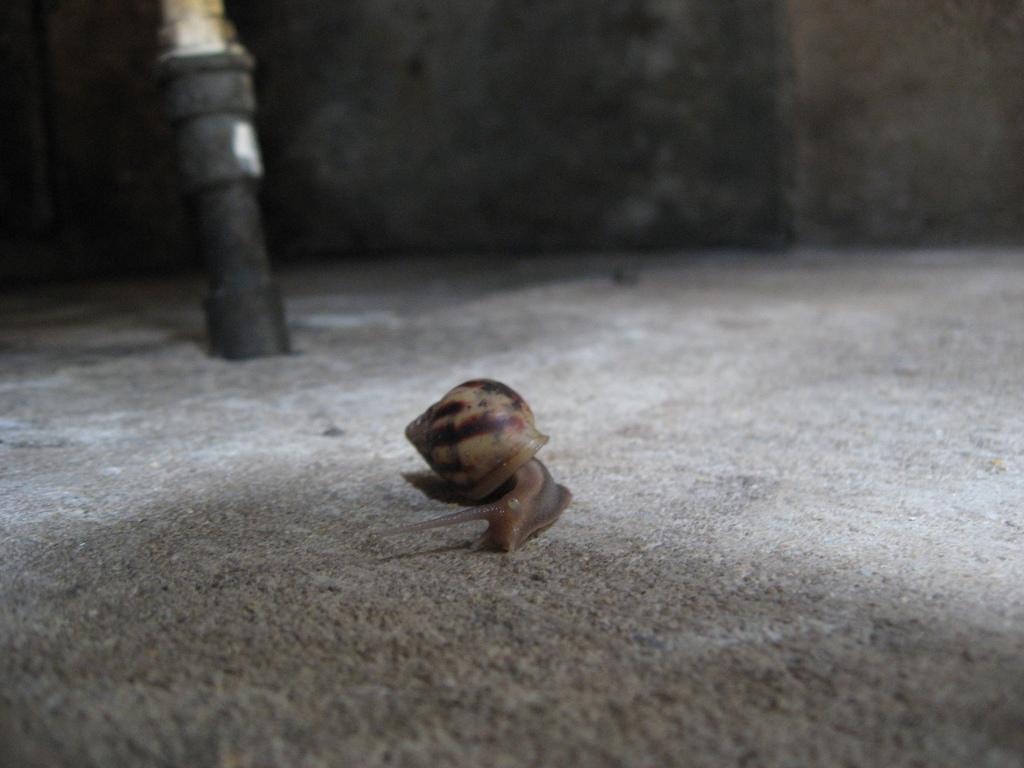Can you describe this image briefly? In this image we can see a snail on a surface. Behind the snail we can see a black object and a wall. 